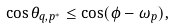Convert formula to latex. <formula><loc_0><loc_0><loc_500><loc_500>\cos \theta _ { q , p ^ { * } } \leq \cos ( \phi - \omega _ { p } ) ,</formula> 